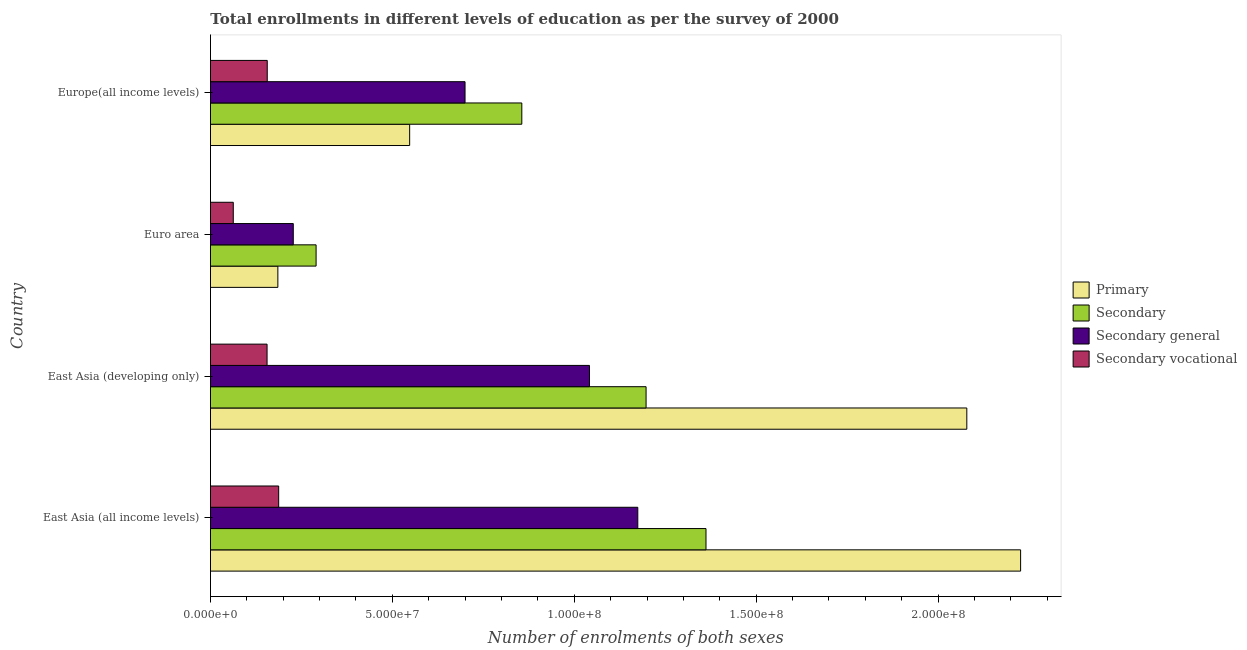How many different coloured bars are there?
Make the answer very short. 4. How many groups of bars are there?
Make the answer very short. 4. How many bars are there on the 4th tick from the bottom?
Make the answer very short. 4. What is the label of the 4th group of bars from the top?
Offer a terse response. East Asia (all income levels). What is the number of enrolments in primary education in Euro area?
Your answer should be very brief. 1.85e+07. Across all countries, what is the maximum number of enrolments in secondary vocational education?
Provide a short and direct response. 1.87e+07. Across all countries, what is the minimum number of enrolments in primary education?
Offer a terse response. 1.85e+07. In which country was the number of enrolments in secondary general education maximum?
Offer a very short reply. East Asia (all income levels). What is the total number of enrolments in secondary general education in the graph?
Your response must be concise. 3.14e+08. What is the difference between the number of enrolments in secondary vocational education in East Asia (all income levels) and that in Euro area?
Provide a short and direct response. 1.25e+07. What is the difference between the number of enrolments in secondary education in Euro area and the number of enrolments in primary education in East Asia (all income levels)?
Give a very brief answer. -1.94e+08. What is the average number of enrolments in secondary education per country?
Offer a very short reply. 9.26e+07. What is the difference between the number of enrolments in secondary education and number of enrolments in secondary general education in East Asia (developing only)?
Offer a very short reply. 1.56e+07. In how many countries, is the number of enrolments in secondary general education greater than 100000000 ?
Offer a very short reply. 2. What is the ratio of the number of enrolments in secondary education in East Asia (all income levels) to that in Euro area?
Your response must be concise. 4.69. Is the number of enrolments in secondary general education in Euro area less than that in Europe(all income levels)?
Provide a succinct answer. Yes. What is the difference between the highest and the second highest number of enrolments in secondary vocational education?
Offer a very short reply. 3.14e+06. What is the difference between the highest and the lowest number of enrolments in secondary vocational education?
Your answer should be very brief. 1.25e+07. In how many countries, is the number of enrolments in secondary general education greater than the average number of enrolments in secondary general education taken over all countries?
Your answer should be compact. 2. What does the 3rd bar from the top in East Asia (all income levels) represents?
Provide a short and direct response. Secondary. What does the 1st bar from the bottom in East Asia (all income levels) represents?
Your answer should be very brief. Primary. How many countries are there in the graph?
Your answer should be compact. 4. Does the graph contain grids?
Keep it short and to the point. No. What is the title of the graph?
Offer a very short reply. Total enrollments in different levels of education as per the survey of 2000. Does "Australia" appear as one of the legend labels in the graph?
Offer a terse response. No. What is the label or title of the X-axis?
Your response must be concise. Number of enrolments of both sexes. What is the Number of enrolments of both sexes of Primary in East Asia (all income levels)?
Your answer should be very brief. 2.23e+08. What is the Number of enrolments of both sexes in Secondary in East Asia (all income levels)?
Ensure brevity in your answer.  1.36e+08. What is the Number of enrolments of both sexes in Secondary general in East Asia (all income levels)?
Offer a very short reply. 1.17e+08. What is the Number of enrolments of both sexes of Secondary vocational in East Asia (all income levels)?
Provide a short and direct response. 1.87e+07. What is the Number of enrolments of both sexes in Primary in East Asia (developing only)?
Provide a short and direct response. 2.08e+08. What is the Number of enrolments of both sexes of Secondary in East Asia (developing only)?
Keep it short and to the point. 1.20e+08. What is the Number of enrolments of both sexes of Secondary general in East Asia (developing only)?
Offer a terse response. 1.04e+08. What is the Number of enrolments of both sexes of Secondary vocational in East Asia (developing only)?
Ensure brevity in your answer.  1.56e+07. What is the Number of enrolments of both sexes of Primary in Euro area?
Provide a short and direct response. 1.85e+07. What is the Number of enrolments of both sexes in Secondary in Euro area?
Your response must be concise. 2.90e+07. What is the Number of enrolments of both sexes in Secondary general in Euro area?
Keep it short and to the point. 2.28e+07. What is the Number of enrolments of both sexes of Secondary vocational in Euro area?
Your response must be concise. 6.27e+06. What is the Number of enrolments of both sexes in Primary in Europe(all income levels)?
Keep it short and to the point. 5.48e+07. What is the Number of enrolments of both sexes of Secondary in Europe(all income levels)?
Ensure brevity in your answer.  8.56e+07. What is the Number of enrolments of both sexes in Secondary general in Europe(all income levels)?
Make the answer very short. 7.00e+07. What is the Number of enrolments of both sexes of Secondary vocational in Europe(all income levels)?
Give a very brief answer. 1.56e+07. Across all countries, what is the maximum Number of enrolments of both sexes of Primary?
Your answer should be compact. 2.23e+08. Across all countries, what is the maximum Number of enrolments of both sexes in Secondary?
Your answer should be very brief. 1.36e+08. Across all countries, what is the maximum Number of enrolments of both sexes of Secondary general?
Your answer should be very brief. 1.17e+08. Across all countries, what is the maximum Number of enrolments of both sexes in Secondary vocational?
Your answer should be very brief. 1.87e+07. Across all countries, what is the minimum Number of enrolments of both sexes in Primary?
Keep it short and to the point. 1.85e+07. Across all countries, what is the minimum Number of enrolments of both sexes of Secondary?
Your answer should be compact. 2.90e+07. Across all countries, what is the minimum Number of enrolments of both sexes in Secondary general?
Your answer should be compact. 2.28e+07. Across all countries, what is the minimum Number of enrolments of both sexes of Secondary vocational?
Offer a very short reply. 6.27e+06. What is the total Number of enrolments of both sexes in Primary in the graph?
Provide a succinct answer. 5.04e+08. What is the total Number of enrolments of both sexes in Secondary in the graph?
Ensure brevity in your answer.  3.71e+08. What is the total Number of enrolments of both sexes in Secondary general in the graph?
Offer a terse response. 3.14e+08. What is the total Number of enrolments of both sexes of Secondary vocational in the graph?
Provide a short and direct response. 5.62e+07. What is the difference between the Number of enrolments of both sexes in Primary in East Asia (all income levels) and that in East Asia (developing only)?
Make the answer very short. 1.48e+07. What is the difference between the Number of enrolments of both sexes in Secondary in East Asia (all income levels) and that in East Asia (developing only)?
Your response must be concise. 1.65e+07. What is the difference between the Number of enrolments of both sexes of Secondary general in East Asia (all income levels) and that in East Asia (developing only)?
Your answer should be compact. 1.33e+07. What is the difference between the Number of enrolments of both sexes in Secondary vocational in East Asia (all income levels) and that in East Asia (developing only)?
Give a very brief answer. 3.19e+06. What is the difference between the Number of enrolments of both sexes in Primary in East Asia (all income levels) and that in Euro area?
Make the answer very short. 2.04e+08. What is the difference between the Number of enrolments of both sexes of Secondary in East Asia (all income levels) and that in Euro area?
Your answer should be compact. 1.07e+08. What is the difference between the Number of enrolments of both sexes of Secondary general in East Asia (all income levels) and that in Euro area?
Give a very brief answer. 9.47e+07. What is the difference between the Number of enrolments of both sexes in Secondary vocational in East Asia (all income levels) and that in Euro area?
Give a very brief answer. 1.25e+07. What is the difference between the Number of enrolments of both sexes in Primary in East Asia (all income levels) and that in Europe(all income levels)?
Keep it short and to the point. 1.68e+08. What is the difference between the Number of enrolments of both sexes of Secondary in East Asia (all income levels) and that in Europe(all income levels)?
Provide a short and direct response. 5.06e+07. What is the difference between the Number of enrolments of both sexes in Secondary general in East Asia (all income levels) and that in Europe(all income levels)?
Your answer should be compact. 4.75e+07. What is the difference between the Number of enrolments of both sexes in Secondary vocational in East Asia (all income levels) and that in Europe(all income levels)?
Your answer should be very brief. 3.14e+06. What is the difference between the Number of enrolments of both sexes in Primary in East Asia (developing only) and that in Euro area?
Make the answer very short. 1.89e+08. What is the difference between the Number of enrolments of both sexes in Secondary in East Asia (developing only) and that in Euro area?
Provide a short and direct response. 9.07e+07. What is the difference between the Number of enrolments of both sexes in Secondary general in East Asia (developing only) and that in Euro area?
Make the answer very short. 8.14e+07. What is the difference between the Number of enrolments of both sexes of Secondary vocational in East Asia (developing only) and that in Euro area?
Your answer should be very brief. 9.29e+06. What is the difference between the Number of enrolments of both sexes in Primary in East Asia (developing only) and that in Europe(all income levels)?
Provide a succinct answer. 1.53e+08. What is the difference between the Number of enrolments of both sexes in Secondary in East Asia (developing only) and that in Europe(all income levels)?
Make the answer very short. 3.42e+07. What is the difference between the Number of enrolments of both sexes in Secondary general in East Asia (developing only) and that in Europe(all income levels)?
Give a very brief answer. 3.42e+07. What is the difference between the Number of enrolments of both sexes in Secondary vocational in East Asia (developing only) and that in Europe(all income levels)?
Offer a terse response. -5.04e+04. What is the difference between the Number of enrolments of both sexes in Primary in Euro area and that in Europe(all income levels)?
Offer a terse response. -3.62e+07. What is the difference between the Number of enrolments of both sexes in Secondary in Euro area and that in Europe(all income levels)?
Provide a succinct answer. -5.65e+07. What is the difference between the Number of enrolments of both sexes in Secondary general in Euro area and that in Europe(all income levels)?
Ensure brevity in your answer.  -4.72e+07. What is the difference between the Number of enrolments of both sexes of Secondary vocational in Euro area and that in Europe(all income levels)?
Offer a very short reply. -9.34e+06. What is the difference between the Number of enrolments of both sexes of Primary in East Asia (all income levels) and the Number of enrolments of both sexes of Secondary in East Asia (developing only)?
Make the answer very short. 1.03e+08. What is the difference between the Number of enrolments of both sexes of Primary in East Asia (all income levels) and the Number of enrolments of both sexes of Secondary general in East Asia (developing only)?
Ensure brevity in your answer.  1.19e+08. What is the difference between the Number of enrolments of both sexes of Primary in East Asia (all income levels) and the Number of enrolments of both sexes of Secondary vocational in East Asia (developing only)?
Keep it short and to the point. 2.07e+08. What is the difference between the Number of enrolments of both sexes in Secondary in East Asia (all income levels) and the Number of enrolments of both sexes in Secondary general in East Asia (developing only)?
Provide a succinct answer. 3.20e+07. What is the difference between the Number of enrolments of both sexes of Secondary in East Asia (all income levels) and the Number of enrolments of both sexes of Secondary vocational in East Asia (developing only)?
Provide a short and direct response. 1.21e+08. What is the difference between the Number of enrolments of both sexes of Secondary general in East Asia (all income levels) and the Number of enrolments of both sexes of Secondary vocational in East Asia (developing only)?
Your response must be concise. 1.02e+08. What is the difference between the Number of enrolments of both sexes of Primary in East Asia (all income levels) and the Number of enrolments of both sexes of Secondary in Euro area?
Provide a succinct answer. 1.94e+08. What is the difference between the Number of enrolments of both sexes in Primary in East Asia (all income levels) and the Number of enrolments of both sexes in Secondary general in Euro area?
Give a very brief answer. 2.00e+08. What is the difference between the Number of enrolments of both sexes of Primary in East Asia (all income levels) and the Number of enrolments of both sexes of Secondary vocational in Euro area?
Offer a very short reply. 2.16e+08. What is the difference between the Number of enrolments of both sexes of Secondary in East Asia (all income levels) and the Number of enrolments of both sexes of Secondary general in Euro area?
Give a very brief answer. 1.13e+08. What is the difference between the Number of enrolments of both sexes in Secondary in East Asia (all income levels) and the Number of enrolments of both sexes in Secondary vocational in Euro area?
Your response must be concise. 1.30e+08. What is the difference between the Number of enrolments of both sexes in Secondary general in East Asia (all income levels) and the Number of enrolments of both sexes in Secondary vocational in Euro area?
Keep it short and to the point. 1.11e+08. What is the difference between the Number of enrolments of both sexes of Primary in East Asia (all income levels) and the Number of enrolments of both sexes of Secondary in Europe(all income levels)?
Offer a terse response. 1.37e+08. What is the difference between the Number of enrolments of both sexes in Primary in East Asia (all income levels) and the Number of enrolments of both sexes in Secondary general in Europe(all income levels)?
Offer a very short reply. 1.53e+08. What is the difference between the Number of enrolments of both sexes of Primary in East Asia (all income levels) and the Number of enrolments of both sexes of Secondary vocational in Europe(all income levels)?
Offer a terse response. 2.07e+08. What is the difference between the Number of enrolments of both sexes of Secondary in East Asia (all income levels) and the Number of enrolments of both sexes of Secondary general in Europe(all income levels)?
Your answer should be compact. 6.62e+07. What is the difference between the Number of enrolments of both sexes of Secondary in East Asia (all income levels) and the Number of enrolments of both sexes of Secondary vocational in Europe(all income levels)?
Give a very brief answer. 1.21e+08. What is the difference between the Number of enrolments of both sexes in Secondary general in East Asia (all income levels) and the Number of enrolments of both sexes in Secondary vocational in Europe(all income levels)?
Provide a short and direct response. 1.02e+08. What is the difference between the Number of enrolments of both sexes in Primary in East Asia (developing only) and the Number of enrolments of both sexes in Secondary in Euro area?
Provide a succinct answer. 1.79e+08. What is the difference between the Number of enrolments of both sexes in Primary in East Asia (developing only) and the Number of enrolments of both sexes in Secondary general in Euro area?
Offer a terse response. 1.85e+08. What is the difference between the Number of enrolments of both sexes of Primary in East Asia (developing only) and the Number of enrolments of both sexes of Secondary vocational in Euro area?
Ensure brevity in your answer.  2.02e+08. What is the difference between the Number of enrolments of both sexes in Secondary in East Asia (developing only) and the Number of enrolments of both sexes in Secondary general in Euro area?
Give a very brief answer. 9.70e+07. What is the difference between the Number of enrolments of both sexes of Secondary in East Asia (developing only) and the Number of enrolments of both sexes of Secondary vocational in Euro area?
Provide a succinct answer. 1.13e+08. What is the difference between the Number of enrolments of both sexes of Secondary general in East Asia (developing only) and the Number of enrolments of both sexes of Secondary vocational in Euro area?
Your response must be concise. 9.79e+07. What is the difference between the Number of enrolments of both sexes in Primary in East Asia (developing only) and the Number of enrolments of both sexes in Secondary in Europe(all income levels)?
Your answer should be compact. 1.22e+08. What is the difference between the Number of enrolments of both sexes of Primary in East Asia (developing only) and the Number of enrolments of both sexes of Secondary general in Europe(all income levels)?
Keep it short and to the point. 1.38e+08. What is the difference between the Number of enrolments of both sexes of Primary in East Asia (developing only) and the Number of enrolments of both sexes of Secondary vocational in Europe(all income levels)?
Give a very brief answer. 1.92e+08. What is the difference between the Number of enrolments of both sexes in Secondary in East Asia (developing only) and the Number of enrolments of both sexes in Secondary general in Europe(all income levels)?
Make the answer very short. 4.98e+07. What is the difference between the Number of enrolments of both sexes in Secondary in East Asia (developing only) and the Number of enrolments of both sexes in Secondary vocational in Europe(all income levels)?
Offer a very short reply. 1.04e+08. What is the difference between the Number of enrolments of both sexes in Secondary general in East Asia (developing only) and the Number of enrolments of both sexes in Secondary vocational in Europe(all income levels)?
Give a very brief answer. 8.86e+07. What is the difference between the Number of enrolments of both sexes in Primary in Euro area and the Number of enrolments of both sexes in Secondary in Europe(all income levels)?
Provide a short and direct response. -6.71e+07. What is the difference between the Number of enrolments of both sexes of Primary in Euro area and the Number of enrolments of both sexes of Secondary general in Europe(all income levels)?
Keep it short and to the point. -5.15e+07. What is the difference between the Number of enrolments of both sexes of Primary in Euro area and the Number of enrolments of both sexes of Secondary vocational in Europe(all income levels)?
Provide a short and direct response. 2.92e+06. What is the difference between the Number of enrolments of both sexes of Secondary in Euro area and the Number of enrolments of both sexes of Secondary general in Europe(all income levels)?
Provide a succinct answer. -4.09e+07. What is the difference between the Number of enrolments of both sexes of Secondary in Euro area and the Number of enrolments of both sexes of Secondary vocational in Europe(all income levels)?
Keep it short and to the point. 1.34e+07. What is the difference between the Number of enrolments of both sexes in Secondary general in Euro area and the Number of enrolments of both sexes in Secondary vocational in Europe(all income levels)?
Your answer should be compact. 7.16e+06. What is the average Number of enrolments of both sexes in Primary per country?
Offer a very short reply. 1.26e+08. What is the average Number of enrolments of both sexes in Secondary per country?
Ensure brevity in your answer.  9.26e+07. What is the average Number of enrolments of both sexes in Secondary general per country?
Ensure brevity in your answer.  7.86e+07. What is the average Number of enrolments of both sexes of Secondary vocational per country?
Your response must be concise. 1.40e+07. What is the difference between the Number of enrolments of both sexes of Primary and Number of enrolments of both sexes of Secondary in East Asia (all income levels)?
Keep it short and to the point. 8.65e+07. What is the difference between the Number of enrolments of both sexes in Primary and Number of enrolments of both sexes in Secondary general in East Asia (all income levels)?
Provide a short and direct response. 1.05e+08. What is the difference between the Number of enrolments of both sexes of Primary and Number of enrolments of both sexes of Secondary vocational in East Asia (all income levels)?
Your response must be concise. 2.04e+08. What is the difference between the Number of enrolments of both sexes in Secondary and Number of enrolments of both sexes in Secondary general in East Asia (all income levels)?
Your answer should be very brief. 1.87e+07. What is the difference between the Number of enrolments of both sexes of Secondary and Number of enrolments of both sexes of Secondary vocational in East Asia (all income levels)?
Offer a terse response. 1.17e+08. What is the difference between the Number of enrolments of both sexes of Secondary general and Number of enrolments of both sexes of Secondary vocational in East Asia (all income levels)?
Offer a terse response. 9.87e+07. What is the difference between the Number of enrolments of both sexes in Primary and Number of enrolments of both sexes in Secondary in East Asia (developing only)?
Your answer should be compact. 8.82e+07. What is the difference between the Number of enrolments of both sexes in Primary and Number of enrolments of both sexes in Secondary general in East Asia (developing only)?
Provide a succinct answer. 1.04e+08. What is the difference between the Number of enrolments of both sexes of Primary and Number of enrolments of both sexes of Secondary vocational in East Asia (developing only)?
Your answer should be very brief. 1.92e+08. What is the difference between the Number of enrolments of both sexes in Secondary and Number of enrolments of both sexes in Secondary general in East Asia (developing only)?
Give a very brief answer. 1.56e+07. What is the difference between the Number of enrolments of both sexes of Secondary and Number of enrolments of both sexes of Secondary vocational in East Asia (developing only)?
Ensure brevity in your answer.  1.04e+08. What is the difference between the Number of enrolments of both sexes in Secondary general and Number of enrolments of both sexes in Secondary vocational in East Asia (developing only)?
Your answer should be very brief. 8.86e+07. What is the difference between the Number of enrolments of both sexes of Primary and Number of enrolments of both sexes of Secondary in Euro area?
Ensure brevity in your answer.  -1.05e+07. What is the difference between the Number of enrolments of both sexes of Primary and Number of enrolments of both sexes of Secondary general in Euro area?
Offer a terse response. -4.24e+06. What is the difference between the Number of enrolments of both sexes of Primary and Number of enrolments of both sexes of Secondary vocational in Euro area?
Give a very brief answer. 1.23e+07. What is the difference between the Number of enrolments of both sexes of Secondary and Number of enrolments of both sexes of Secondary general in Euro area?
Ensure brevity in your answer.  6.27e+06. What is the difference between the Number of enrolments of both sexes of Secondary and Number of enrolments of both sexes of Secondary vocational in Euro area?
Keep it short and to the point. 2.28e+07. What is the difference between the Number of enrolments of both sexes of Secondary general and Number of enrolments of both sexes of Secondary vocational in Euro area?
Offer a terse response. 1.65e+07. What is the difference between the Number of enrolments of both sexes in Primary and Number of enrolments of both sexes in Secondary in Europe(all income levels)?
Provide a short and direct response. -3.08e+07. What is the difference between the Number of enrolments of both sexes in Primary and Number of enrolments of both sexes in Secondary general in Europe(all income levels)?
Provide a succinct answer. -1.52e+07. What is the difference between the Number of enrolments of both sexes of Primary and Number of enrolments of both sexes of Secondary vocational in Europe(all income levels)?
Make the answer very short. 3.91e+07. What is the difference between the Number of enrolments of both sexes of Secondary and Number of enrolments of both sexes of Secondary general in Europe(all income levels)?
Offer a terse response. 1.56e+07. What is the difference between the Number of enrolments of both sexes of Secondary and Number of enrolments of both sexes of Secondary vocational in Europe(all income levels)?
Make the answer very short. 7.00e+07. What is the difference between the Number of enrolments of both sexes of Secondary general and Number of enrolments of both sexes of Secondary vocational in Europe(all income levels)?
Give a very brief answer. 5.44e+07. What is the ratio of the Number of enrolments of both sexes in Primary in East Asia (all income levels) to that in East Asia (developing only)?
Your response must be concise. 1.07. What is the ratio of the Number of enrolments of both sexes in Secondary in East Asia (all income levels) to that in East Asia (developing only)?
Keep it short and to the point. 1.14. What is the ratio of the Number of enrolments of both sexes of Secondary general in East Asia (all income levels) to that in East Asia (developing only)?
Your response must be concise. 1.13. What is the ratio of the Number of enrolments of both sexes of Secondary vocational in East Asia (all income levels) to that in East Asia (developing only)?
Make the answer very short. 1.21. What is the ratio of the Number of enrolments of both sexes in Primary in East Asia (all income levels) to that in Euro area?
Keep it short and to the point. 12.02. What is the ratio of the Number of enrolments of both sexes in Secondary in East Asia (all income levels) to that in Euro area?
Make the answer very short. 4.69. What is the ratio of the Number of enrolments of both sexes of Secondary general in East Asia (all income levels) to that in Euro area?
Your answer should be compact. 5.16. What is the ratio of the Number of enrolments of both sexes in Secondary vocational in East Asia (all income levels) to that in Euro area?
Provide a succinct answer. 2.99. What is the ratio of the Number of enrolments of both sexes in Primary in East Asia (all income levels) to that in Europe(all income levels)?
Your answer should be very brief. 4.07. What is the ratio of the Number of enrolments of both sexes of Secondary in East Asia (all income levels) to that in Europe(all income levels)?
Make the answer very short. 1.59. What is the ratio of the Number of enrolments of both sexes of Secondary general in East Asia (all income levels) to that in Europe(all income levels)?
Give a very brief answer. 1.68. What is the ratio of the Number of enrolments of both sexes in Secondary vocational in East Asia (all income levels) to that in Europe(all income levels)?
Provide a succinct answer. 1.2. What is the ratio of the Number of enrolments of both sexes of Primary in East Asia (developing only) to that in Euro area?
Your answer should be compact. 11.22. What is the ratio of the Number of enrolments of both sexes of Secondary in East Asia (developing only) to that in Euro area?
Ensure brevity in your answer.  4.12. What is the ratio of the Number of enrolments of both sexes of Secondary general in East Asia (developing only) to that in Euro area?
Your response must be concise. 4.58. What is the ratio of the Number of enrolments of both sexes of Secondary vocational in East Asia (developing only) to that in Euro area?
Your answer should be compact. 2.48. What is the ratio of the Number of enrolments of both sexes of Primary in East Asia (developing only) to that in Europe(all income levels)?
Offer a very short reply. 3.8. What is the ratio of the Number of enrolments of both sexes in Secondary in East Asia (developing only) to that in Europe(all income levels)?
Provide a succinct answer. 1.4. What is the ratio of the Number of enrolments of both sexes in Secondary general in East Asia (developing only) to that in Europe(all income levels)?
Your answer should be compact. 1.49. What is the ratio of the Number of enrolments of both sexes of Primary in Euro area to that in Europe(all income levels)?
Give a very brief answer. 0.34. What is the ratio of the Number of enrolments of both sexes of Secondary in Euro area to that in Europe(all income levels)?
Make the answer very short. 0.34. What is the ratio of the Number of enrolments of both sexes in Secondary general in Euro area to that in Europe(all income levels)?
Offer a very short reply. 0.33. What is the ratio of the Number of enrolments of both sexes of Secondary vocational in Euro area to that in Europe(all income levels)?
Your answer should be very brief. 0.4. What is the difference between the highest and the second highest Number of enrolments of both sexes in Primary?
Your answer should be very brief. 1.48e+07. What is the difference between the highest and the second highest Number of enrolments of both sexes in Secondary?
Make the answer very short. 1.65e+07. What is the difference between the highest and the second highest Number of enrolments of both sexes of Secondary general?
Give a very brief answer. 1.33e+07. What is the difference between the highest and the second highest Number of enrolments of both sexes of Secondary vocational?
Offer a very short reply. 3.14e+06. What is the difference between the highest and the lowest Number of enrolments of both sexes of Primary?
Provide a succinct answer. 2.04e+08. What is the difference between the highest and the lowest Number of enrolments of both sexes in Secondary?
Give a very brief answer. 1.07e+08. What is the difference between the highest and the lowest Number of enrolments of both sexes in Secondary general?
Provide a short and direct response. 9.47e+07. What is the difference between the highest and the lowest Number of enrolments of both sexes in Secondary vocational?
Your answer should be compact. 1.25e+07. 